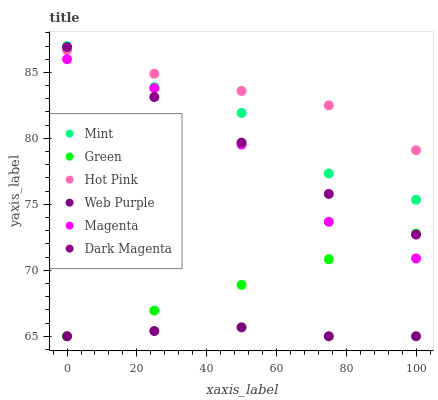Does Web Purple have the minimum area under the curve?
Answer yes or no. Yes. Does Hot Pink have the maximum area under the curve?
Answer yes or no. Yes. Does Hot Pink have the minimum area under the curve?
Answer yes or no. No. Does Web Purple have the maximum area under the curve?
Answer yes or no. No. Is Green the smoothest?
Answer yes or no. Yes. Is Magenta the roughest?
Answer yes or no. Yes. Is Hot Pink the smoothest?
Answer yes or no. No. Is Hot Pink the roughest?
Answer yes or no. No. Does Web Purple have the lowest value?
Answer yes or no. Yes. Does Hot Pink have the lowest value?
Answer yes or no. No. Does Mint have the highest value?
Answer yes or no. Yes. Does Hot Pink have the highest value?
Answer yes or no. No. Is Web Purple less than Hot Pink?
Answer yes or no. Yes. Is Mint greater than Web Purple?
Answer yes or no. Yes. Does Green intersect Web Purple?
Answer yes or no. Yes. Is Green less than Web Purple?
Answer yes or no. No. Is Green greater than Web Purple?
Answer yes or no. No. Does Web Purple intersect Hot Pink?
Answer yes or no. No. 